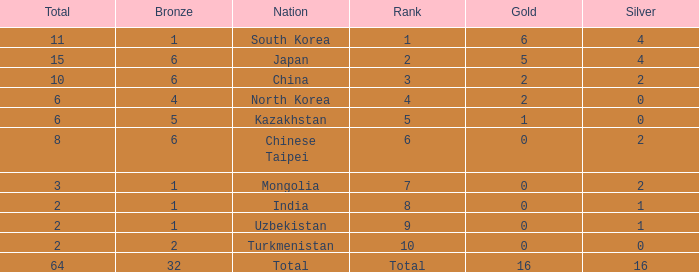What is the total Gold's less than 0? 0.0. 